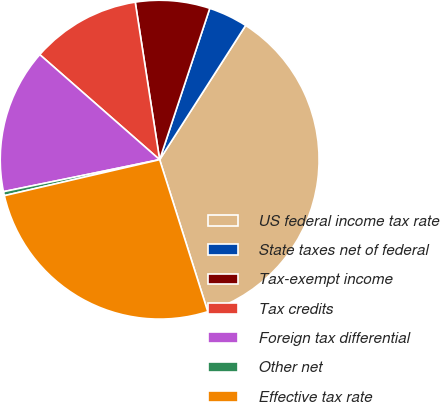<chart> <loc_0><loc_0><loc_500><loc_500><pie_chart><fcel>US federal income tax rate<fcel>State taxes net of federal<fcel>Tax-exempt income<fcel>Tax credits<fcel>Foreign tax differential<fcel>Other net<fcel>Effective tax rate<nl><fcel>36.05%<fcel>3.98%<fcel>7.54%<fcel>11.1%<fcel>14.67%<fcel>0.41%<fcel>26.26%<nl></chart> 